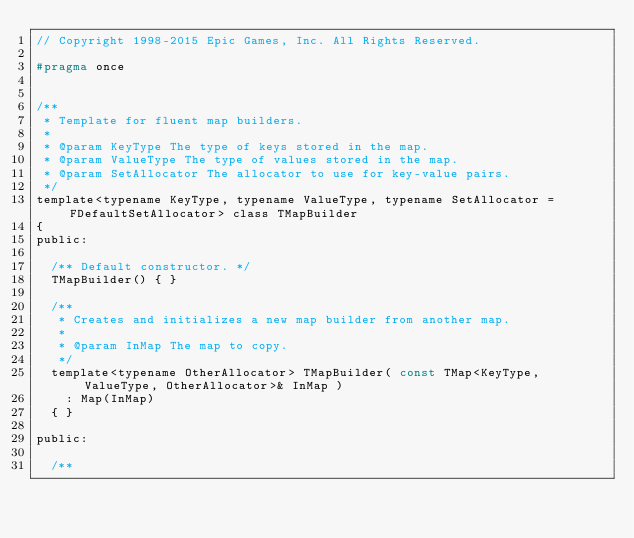Convert code to text. <code><loc_0><loc_0><loc_500><loc_500><_C_>// Copyright 1998-2015 Epic Games, Inc. All Rights Reserved.

#pragma once


/**
 * Template for fluent map builders.
 *
 * @param KeyType The type of keys stored in the map.
 * @param ValueType The type of values stored in the map.
 * @param SetAllocator The allocator to use for key-value pairs.
 */
template<typename KeyType, typename ValueType, typename SetAllocator = FDefaultSetAllocator> class TMapBuilder
{
public:

	/** Default constructor. */
	TMapBuilder() { }

	/**
	 * Creates and initializes a new map builder from another map.
	 *
	 * @param InMap The map to copy.
	 */
	template<typename OtherAllocator> TMapBuilder( const TMap<KeyType, ValueType, OtherAllocator>& InMap )
		: Map(InMap)
	{ }

public:

	/**</code> 